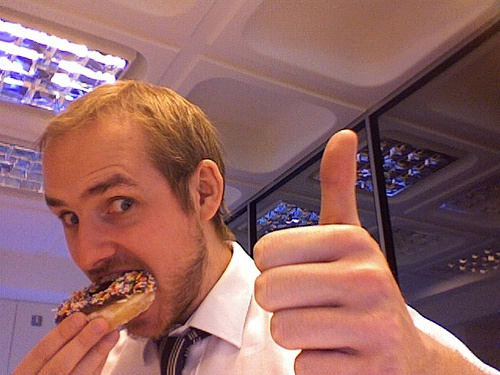Describe the objects in this image and their specific colors. I can see people in salmon and brown tones, donut in salmon, maroon, brown, and tan tones, and tie in salmon, black, maroon, and brown tones in this image. 